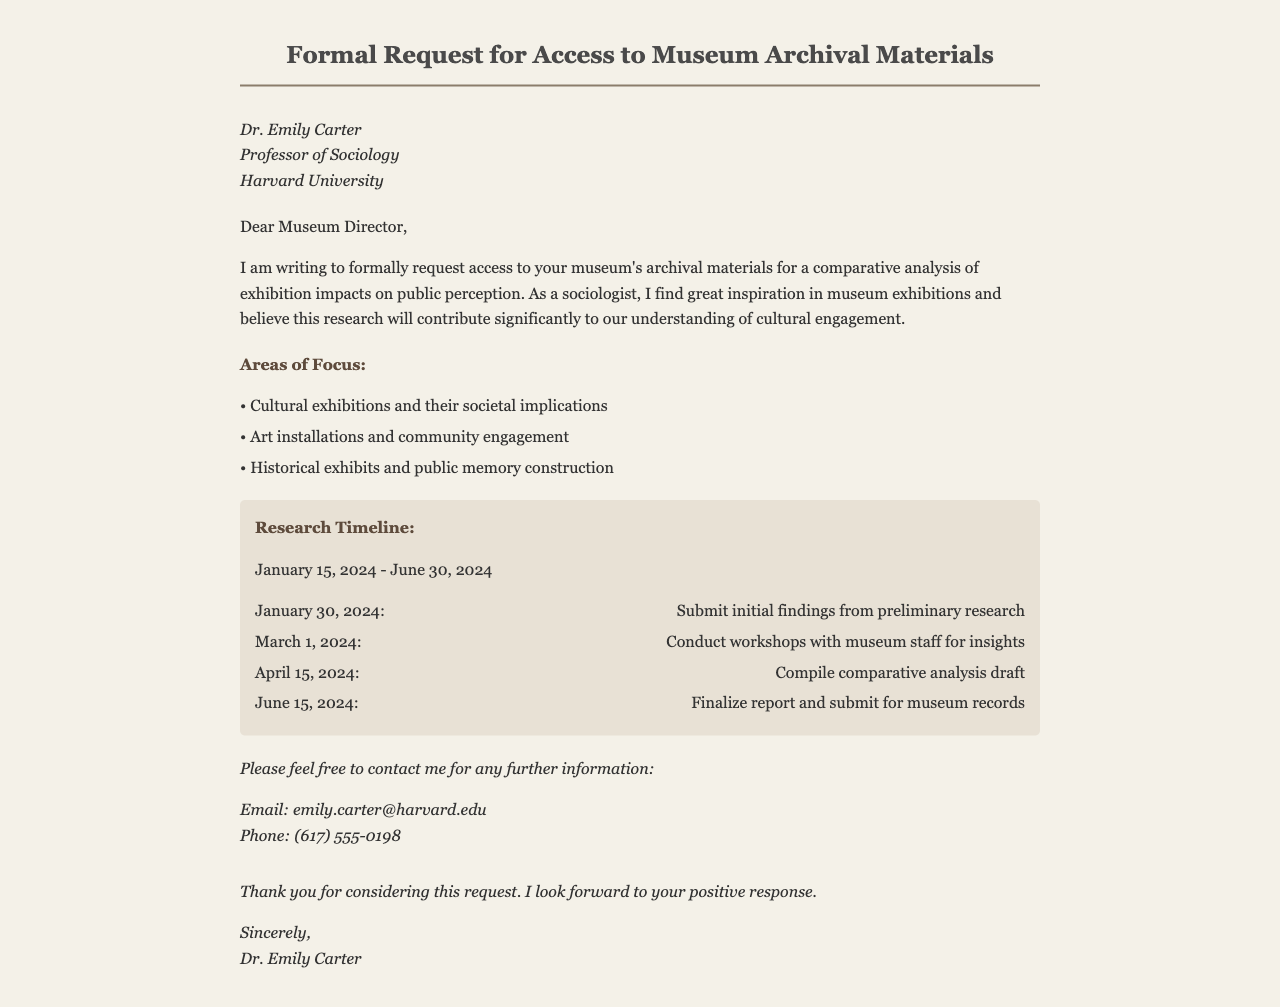What is the title of the document? The title is clearly stated at the top of the document and indicates the purpose of the request.
Answer: Formal Request for Access to Museum Archival Materials Who is the author of the letter? The author is mentioned in the section that includes their professional details.
Answer: Dr. Emily Carter What is the research timeline for the project? The timeline is provided in a dedicated section that lists the start and end dates of the research.
Answer: January 15, 2024 - June 30, 2024 What is one area of focus mentioned in the letter? The letter lists several areas of focus that the research will cover.
Answer: Cultural exhibitions and their societal implications When is the final report due to be submitted? The timeline includes a specific date for the final report submission.
Answer: June 15, 2024 What email address is provided for contact? The contact information is provided at the end of the document for further communication.
Answer: emily.carter@harvard.edu What action is planned for March 1, 2024? The timeline outlines various scheduled activities, including the one on this specific date.
Answer: Conduct workshops with museum staff for insights What is the underlying theme of the research? The purpose of the research reflected in the letter points towards an overarching theme.
Answer: Comparative analysis of exhibition impacts on public perception What does Dr. Emily Carter hope to achieve with her request? The intent of the request is inferred from the letter's purpose as stated by the author.
Answer: Access to archival materials for research 